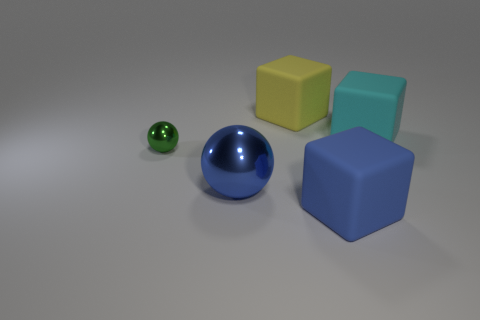Are there fewer big rubber things in front of the tiny green metallic ball than big green metallic cylinders? Actually, in the image, we can observe only one big blue rubber ball, while there are no big green metallic cylinders present at all. So, to answer your question, there are not fewer big rubber things in front of the tiny green metallic ball than big green metallic cylinders, simply because the latter are nonexistent in the scene. 